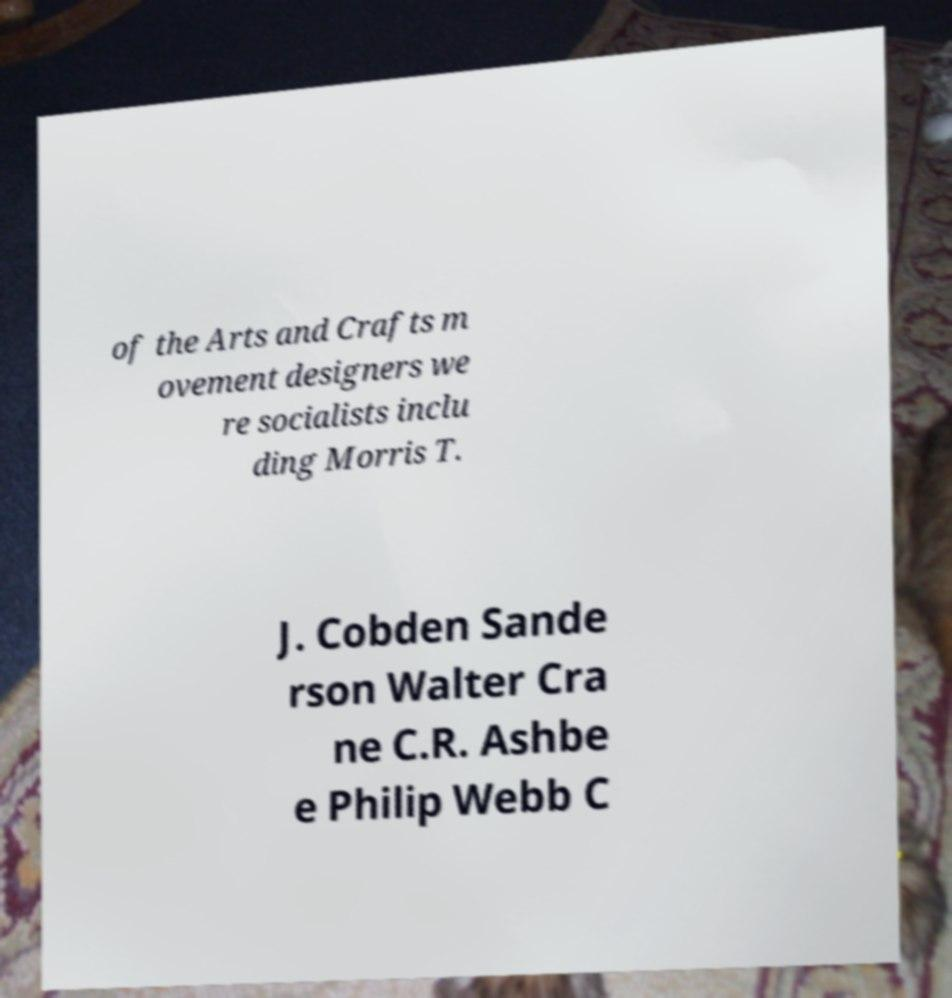Can you read and provide the text displayed in the image?This photo seems to have some interesting text. Can you extract and type it out for me? of the Arts and Crafts m ovement designers we re socialists inclu ding Morris T. J. Cobden Sande rson Walter Cra ne C.R. Ashbe e Philip Webb C 